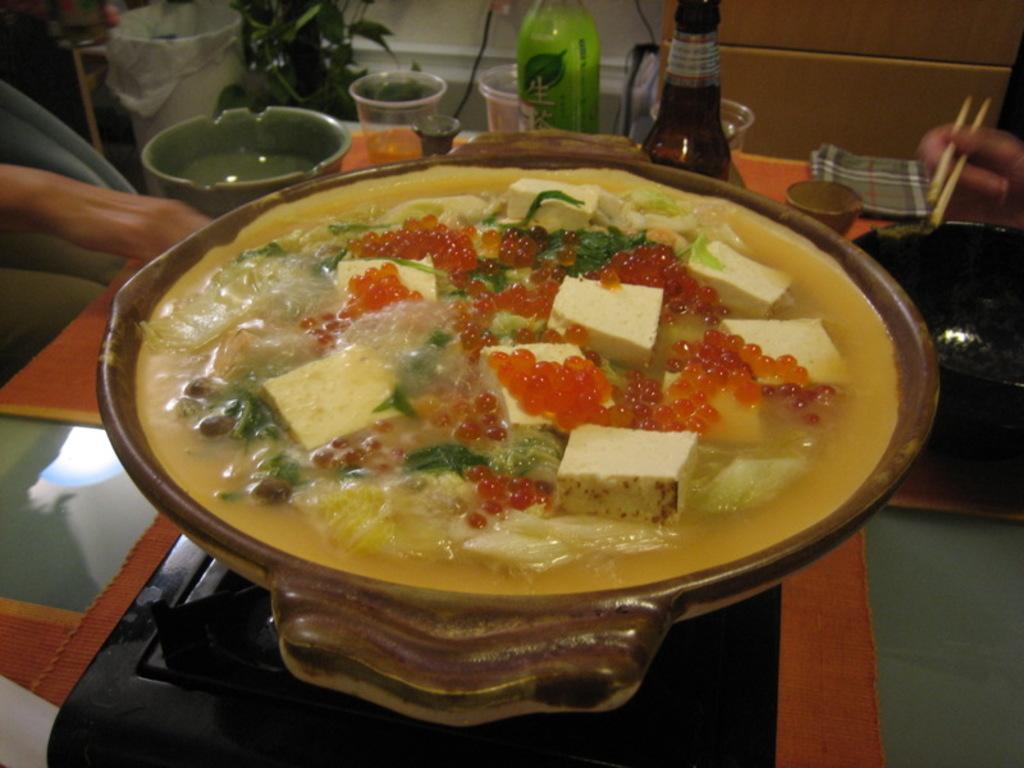Can you describe this image briefly? Here in this picture we can see a soup with vegetables in it present in a bowl, which is present on the stove, on the table present over there and we can also see other bowls, glasses and bottles all present on the table over there and we can see persons hands on either side and on the top left we can see a dustbin and plants present over there. 